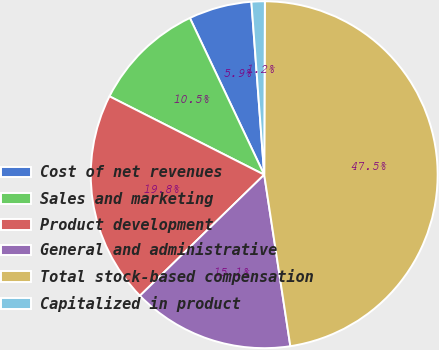Convert chart to OTSL. <chart><loc_0><loc_0><loc_500><loc_500><pie_chart><fcel>Cost of net revenues<fcel>Sales and marketing<fcel>Product development<fcel>General and administrative<fcel>Total stock-based compensation<fcel>Capitalized in product<nl><fcel>5.87%<fcel>10.49%<fcel>19.75%<fcel>15.12%<fcel>47.53%<fcel>1.24%<nl></chart> 